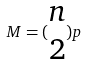Convert formula to latex. <formula><loc_0><loc_0><loc_500><loc_500>M = ( \begin{matrix} n \\ 2 \end{matrix} ) p</formula> 